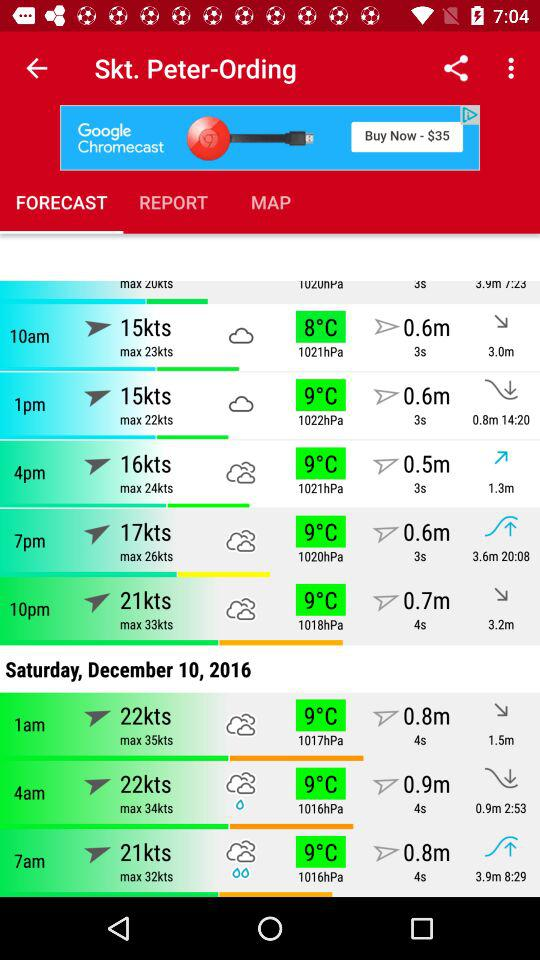How many hours are between the 10pm and 1am entries?
Answer the question using a single word or phrase. 3 